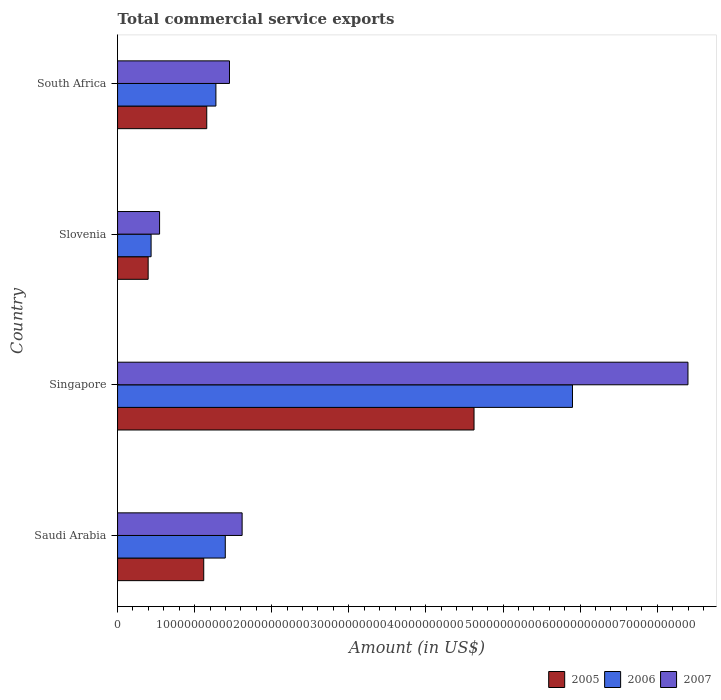How many groups of bars are there?
Ensure brevity in your answer.  4. How many bars are there on the 3rd tick from the bottom?
Your response must be concise. 3. What is the label of the 4th group of bars from the top?
Offer a very short reply. Saudi Arabia. What is the total commercial service exports in 2007 in Saudi Arabia?
Offer a very short reply. 1.62e+1. Across all countries, what is the maximum total commercial service exports in 2007?
Give a very brief answer. 7.40e+1. Across all countries, what is the minimum total commercial service exports in 2007?
Offer a terse response. 5.45e+09. In which country was the total commercial service exports in 2007 maximum?
Make the answer very short. Singapore. In which country was the total commercial service exports in 2007 minimum?
Offer a terse response. Slovenia. What is the total total commercial service exports in 2006 in the graph?
Offer a very short reply. 9.01e+1. What is the difference between the total commercial service exports in 2005 in Singapore and that in Slovenia?
Provide a succinct answer. 4.23e+1. What is the difference between the total commercial service exports in 2007 in South Africa and the total commercial service exports in 2006 in Singapore?
Your answer should be very brief. -4.45e+1. What is the average total commercial service exports in 2005 per country?
Offer a terse response. 1.82e+1. What is the difference between the total commercial service exports in 2006 and total commercial service exports in 2005 in Singapore?
Keep it short and to the point. 1.28e+1. What is the ratio of the total commercial service exports in 2006 in Saudi Arabia to that in Singapore?
Your answer should be compact. 0.24. Is the total commercial service exports in 2005 in Saudi Arabia less than that in Slovenia?
Ensure brevity in your answer.  No. What is the difference between the highest and the second highest total commercial service exports in 2006?
Your response must be concise. 4.50e+1. What is the difference between the highest and the lowest total commercial service exports in 2006?
Give a very brief answer. 5.47e+1. In how many countries, is the total commercial service exports in 2005 greater than the average total commercial service exports in 2005 taken over all countries?
Make the answer very short. 1. Is the sum of the total commercial service exports in 2006 in Saudi Arabia and Singapore greater than the maximum total commercial service exports in 2007 across all countries?
Keep it short and to the point. No. What does the 1st bar from the top in Slovenia represents?
Offer a very short reply. 2007. Is it the case that in every country, the sum of the total commercial service exports in 2005 and total commercial service exports in 2006 is greater than the total commercial service exports in 2007?
Keep it short and to the point. Yes. How many bars are there?
Make the answer very short. 12. How many countries are there in the graph?
Ensure brevity in your answer.  4. Does the graph contain any zero values?
Keep it short and to the point. No. Does the graph contain grids?
Ensure brevity in your answer.  No. How are the legend labels stacked?
Keep it short and to the point. Horizontal. What is the title of the graph?
Your response must be concise. Total commercial service exports. What is the label or title of the Y-axis?
Keep it short and to the point. Country. What is the Amount (in US$) in 2005 in Saudi Arabia?
Your answer should be compact. 1.12e+1. What is the Amount (in US$) in 2006 in Saudi Arabia?
Make the answer very short. 1.40e+1. What is the Amount (in US$) of 2007 in Saudi Arabia?
Make the answer very short. 1.62e+1. What is the Amount (in US$) in 2005 in Singapore?
Keep it short and to the point. 4.62e+1. What is the Amount (in US$) of 2006 in Singapore?
Provide a succinct answer. 5.90e+1. What is the Amount (in US$) of 2007 in Singapore?
Provide a succinct answer. 7.40e+1. What is the Amount (in US$) of 2005 in Slovenia?
Offer a very short reply. 3.97e+09. What is the Amount (in US$) of 2006 in Slovenia?
Offer a very short reply. 4.35e+09. What is the Amount (in US$) of 2007 in Slovenia?
Your answer should be very brief. 5.45e+09. What is the Amount (in US$) of 2005 in South Africa?
Provide a succinct answer. 1.16e+1. What is the Amount (in US$) of 2006 in South Africa?
Your answer should be very brief. 1.28e+1. What is the Amount (in US$) of 2007 in South Africa?
Offer a terse response. 1.45e+1. Across all countries, what is the maximum Amount (in US$) of 2005?
Provide a short and direct response. 4.62e+1. Across all countries, what is the maximum Amount (in US$) in 2006?
Your answer should be compact. 5.90e+1. Across all countries, what is the maximum Amount (in US$) of 2007?
Provide a short and direct response. 7.40e+1. Across all countries, what is the minimum Amount (in US$) of 2005?
Make the answer very short. 3.97e+09. Across all countries, what is the minimum Amount (in US$) in 2006?
Your answer should be compact. 4.35e+09. Across all countries, what is the minimum Amount (in US$) of 2007?
Provide a succinct answer. 5.45e+09. What is the total Amount (in US$) in 2005 in the graph?
Offer a terse response. 7.30e+1. What is the total Amount (in US$) in 2006 in the graph?
Keep it short and to the point. 9.01e+1. What is the total Amount (in US$) of 2007 in the graph?
Give a very brief answer. 1.10e+11. What is the difference between the Amount (in US$) in 2005 in Saudi Arabia and that in Singapore?
Ensure brevity in your answer.  -3.51e+1. What is the difference between the Amount (in US$) in 2006 in Saudi Arabia and that in Singapore?
Offer a very short reply. -4.50e+1. What is the difference between the Amount (in US$) of 2007 in Saudi Arabia and that in Singapore?
Make the answer very short. -5.78e+1. What is the difference between the Amount (in US$) in 2005 in Saudi Arabia and that in Slovenia?
Make the answer very short. 7.21e+09. What is the difference between the Amount (in US$) of 2006 in Saudi Arabia and that in Slovenia?
Provide a succinct answer. 9.62e+09. What is the difference between the Amount (in US$) of 2007 in Saudi Arabia and that in Slovenia?
Your response must be concise. 1.07e+1. What is the difference between the Amount (in US$) of 2005 in Saudi Arabia and that in South Africa?
Offer a very short reply. -3.91e+08. What is the difference between the Amount (in US$) in 2006 in Saudi Arabia and that in South Africa?
Offer a terse response. 1.22e+09. What is the difference between the Amount (in US$) in 2007 in Saudi Arabia and that in South Africa?
Keep it short and to the point. 1.64e+09. What is the difference between the Amount (in US$) of 2005 in Singapore and that in Slovenia?
Your answer should be compact. 4.23e+1. What is the difference between the Amount (in US$) of 2006 in Singapore and that in Slovenia?
Offer a very short reply. 5.47e+1. What is the difference between the Amount (in US$) in 2007 in Singapore and that in Slovenia?
Keep it short and to the point. 6.85e+1. What is the difference between the Amount (in US$) of 2005 in Singapore and that in South Africa?
Provide a short and direct response. 3.47e+1. What is the difference between the Amount (in US$) of 2006 in Singapore and that in South Africa?
Provide a short and direct response. 4.63e+1. What is the difference between the Amount (in US$) of 2007 in Singapore and that in South Africa?
Your answer should be compact. 5.95e+1. What is the difference between the Amount (in US$) in 2005 in Slovenia and that in South Africa?
Provide a short and direct response. -7.60e+09. What is the difference between the Amount (in US$) of 2006 in Slovenia and that in South Africa?
Your answer should be compact. -8.41e+09. What is the difference between the Amount (in US$) in 2007 in Slovenia and that in South Africa?
Provide a short and direct response. -9.07e+09. What is the difference between the Amount (in US$) of 2005 in Saudi Arabia and the Amount (in US$) of 2006 in Singapore?
Keep it short and to the point. -4.78e+1. What is the difference between the Amount (in US$) in 2005 in Saudi Arabia and the Amount (in US$) in 2007 in Singapore?
Give a very brief answer. -6.28e+1. What is the difference between the Amount (in US$) of 2006 in Saudi Arabia and the Amount (in US$) of 2007 in Singapore?
Keep it short and to the point. -6.00e+1. What is the difference between the Amount (in US$) of 2005 in Saudi Arabia and the Amount (in US$) of 2006 in Slovenia?
Offer a very short reply. 6.83e+09. What is the difference between the Amount (in US$) in 2005 in Saudi Arabia and the Amount (in US$) in 2007 in Slovenia?
Provide a short and direct response. 5.73e+09. What is the difference between the Amount (in US$) in 2006 in Saudi Arabia and the Amount (in US$) in 2007 in Slovenia?
Your answer should be very brief. 8.52e+09. What is the difference between the Amount (in US$) of 2005 in Saudi Arabia and the Amount (in US$) of 2006 in South Africa?
Ensure brevity in your answer.  -1.58e+09. What is the difference between the Amount (in US$) in 2005 in Saudi Arabia and the Amount (in US$) in 2007 in South Africa?
Your answer should be very brief. -3.34e+09. What is the difference between the Amount (in US$) of 2006 in Saudi Arabia and the Amount (in US$) of 2007 in South Africa?
Offer a very short reply. -5.46e+08. What is the difference between the Amount (in US$) of 2005 in Singapore and the Amount (in US$) of 2006 in Slovenia?
Keep it short and to the point. 4.19e+1. What is the difference between the Amount (in US$) in 2005 in Singapore and the Amount (in US$) in 2007 in Slovenia?
Give a very brief answer. 4.08e+1. What is the difference between the Amount (in US$) in 2006 in Singapore and the Amount (in US$) in 2007 in Slovenia?
Your answer should be very brief. 5.36e+1. What is the difference between the Amount (in US$) in 2005 in Singapore and the Amount (in US$) in 2006 in South Africa?
Offer a terse response. 3.35e+1. What is the difference between the Amount (in US$) in 2005 in Singapore and the Amount (in US$) in 2007 in South Africa?
Your answer should be compact. 3.17e+1. What is the difference between the Amount (in US$) of 2006 in Singapore and the Amount (in US$) of 2007 in South Africa?
Provide a succinct answer. 4.45e+1. What is the difference between the Amount (in US$) in 2005 in Slovenia and the Amount (in US$) in 2006 in South Africa?
Provide a succinct answer. -8.79e+09. What is the difference between the Amount (in US$) of 2005 in Slovenia and the Amount (in US$) of 2007 in South Africa?
Your answer should be compact. -1.05e+1. What is the difference between the Amount (in US$) of 2006 in Slovenia and the Amount (in US$) of 2007 in South Africa?
Make the answer very short. -1.02e+1. What is the average Amount (in US$) in 2005 per country?
Your answer should be very brief. 1.82e+1. What is the average Amount (in US$) in 2006 per country?
Make the answer very short. 2.25e+1. What is the average Amount (in US$) of 2007 per country?
Your answer should be compact. 2.75e+1. What is the difference between the Amount (in US$) in 2005 and Amount (in US$) in 2006 in Saudi Arabia?
Offer a very short reply. -2.79e+09. What is the difference between the Amount (in US$) of 2005 and Amount (in US$) of 2007 in Saudi Arabia?
Provide a short and direct response. -4.98e+09. What is the difference between the Amount (in US$) in 2006 and Amount (in US$) in 2007 in Saudi Arabia?
Provide a succinct answer. -2.19e+09. What is the difference between the Amount (in US$) in 2005 and Amount (in US$) in 2006 in Singapore?
Offer a very short reply. -1.28e+1. What is the difference between the Amount (in US$) in 2005 and Amount (in US$) in 2007 in Singapore?
Ensure brevity in your answer.  -2.78e+1. What is the difference between the Amount (in US$) of 2006 and Amount (in US$) of 2007 in Singapore?
Ensure brevity in your answer.  -1.50e+1. What is the difference between the Amount (in US$) in 2005 and Amount (in US$) in 2006 in Slovenia?
Offer a very short reply. -3.80e+08. What is the difference between the Amount (in US$) of 2005 and Amount (in US$) of 2007 in Slovenia?
Your answer should be compact. -1.48e+09. What is the difference between the Amount (in US$) in 2006 and Amount (in US$) in 2007 in Slovenia?
Give a very brief answer. -1.10e+09. What is the difference between the Amount (in US$) of 2005 and Amount (in US$) of 2006 in South Africa?
Provide a short and direct response. -1.19e+09. What is the difference between the Amount (in US$) in 2005 and Amount (in US$) in 2007 in South Africa?
Provide a succinct answer. -2.95e+09. What is the difference between the Amount (in US$) in 2006 and Amount (in US$) in 2007 in South Africa?
Your answer should be compact. -1.76e+09. What is the ratio of the Amount (in US$) in 2005 in Saudi Arabia to that in Singapore?
Keep it short and to the point. 0.24. What is the ratio of the Amount (in US$) in 2006 in Saudi Arabia to that in Singapore?
Offer a terse response. 0.24. What is the ratio of the Amount (in US$) of 2007 in Saudi Arabia to that in Singapore?
Keep it short and to the point. 0.22. What is the ratio of the Amount (in US$) in 2005 in Saudi Arabia to that in Slovenia?
Provide a short and direct response. 2.82. What is the ratio of the Amount (in US$) in 2006 in Saudi Arabia to that in Slovenia?
Provide a succinct answer. 3.21. What is the ratio of the Amount (in US$) in 2007 in Saudi Arabia to that in Slovenia?
Your response must be concise. 2.96. What is the ratio of the Amount (in US$) in 2005 in Saudi Arabia to that in South Africa?
Ensure brevity in your answer.  0.97. What is the ratio of the Amount (in US$) in 2006 in Saudi Arabia to that in South Africa?
Provide a short and direct response. 1.1. What is the ratio of the Amount (in US$) in 2007 in Saudi Arabia to that in South Africa?
Keep it short and to the point. 1.11. What is the ratio of the Amount (in US$) of 2005 in Singapore to that in Slovenia?
Provide a succinct answer. 11.65. What is the ratio of the Amount (in US$) of 2006 in Singapore to that in Slovenia?
Provide a succinct answer. 13.57. What is the ratio of the Amount (in US$) of 2007 in Singapore to that in Slovenia?
Offer a terse response. 13.58. What is the ratio of the Amount (in US$) in 2005 in Singapore to that in South Africa?
Provide a succinct answer. 4. What is the ratio of the Amount (in US$) of 2006 in Singapore to that in South Africa?
Your answer should be compact. 4.63. What is the ratio of the Amount (in US$) of 2007 in Singapore to that in South Africa?
Keep it short and to the point. 5.1. What is the ratio of the Amount (in US$) in 2005 in Slovenia to that in South Africa?
Offer a very short reply. 0.34. What is the ratio of the Amount (in US$) of 2006 in Slovenia to that in South Africa?
Your answer should be compact. 0.34. What is the ratio of the Amount (in US$) in 2007 in Slovenia to that in South Africa?
Your answer should be very brief. 0.38. What is the difference between the highest and the second highest Amount (in US$) in 2005?
Your response must be concise. 3.47e+1. What is the difference between the highest and the second highest Amount (in US$) of 2006?
Offer a very short reply. 4.50e+1. What is the difference between the highest and the second highest Amount (in US$) of 2007?
Keep it short and to the point. 5.78e+1. What is the difference between the highest and the lowest Amount (in US$) of 2005?
Offer a terse response. 4.23e+1. What is the difference between the highest and the lowest Amount (in US$) in 2006?
Your answer should be compact. 5.47e+1. What is the difference between the highest and the lowest Amount (in US$) of 2007?
Provide a succinct answer. 6.85e+1. 